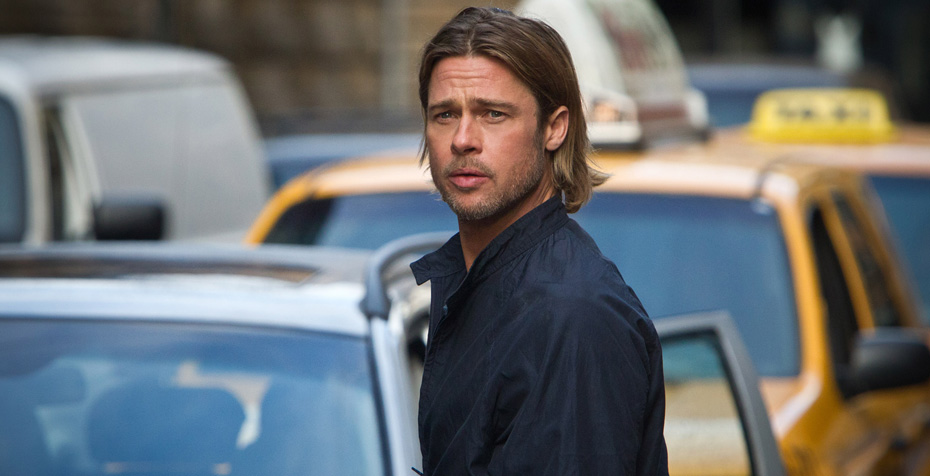Describe a realistic scenario where the man in the image interacts with his surroundings. Jack casually walks down the bustling city street, his focused expression suggesting a man on a mission. He checks his wristwatch and quickens his pace, realizing he is running late for a significant meeting. Passing by the line of parked cars and the iconic yellow taxi, he maneuvers through the crowd, occasionally nodding to familiar faces. The urban landscape around him is lively yet chaotic, filled with the sounds of honking horns and distant chatter. Jack mentally runs through his presentation, determined to make a stellar impression when he arrives.  Imagine an alternate universe where superheroes exist and describe the man’s alter ego. In an alternate universe where superheroes and villains clash amidst towering skyscrapers, Jack Thompson leads a double life. By day, he is a respected architect, known for his innovative designs and sustainable buildings. But as dusk falls, he transforms into 'The Sentinel,' a vigilante hero equipped with advanced technology and unmatched combat skills. His navy blue jacket conceals a high-tech suit beneath, allowing him to seamlessly switch from his civilian persona to his heroic alter ego. The image captures Jack moments before a distress signal alerts him to an imminent threat, ready to leap into action and protect his beloved city with unwavering resolve. 